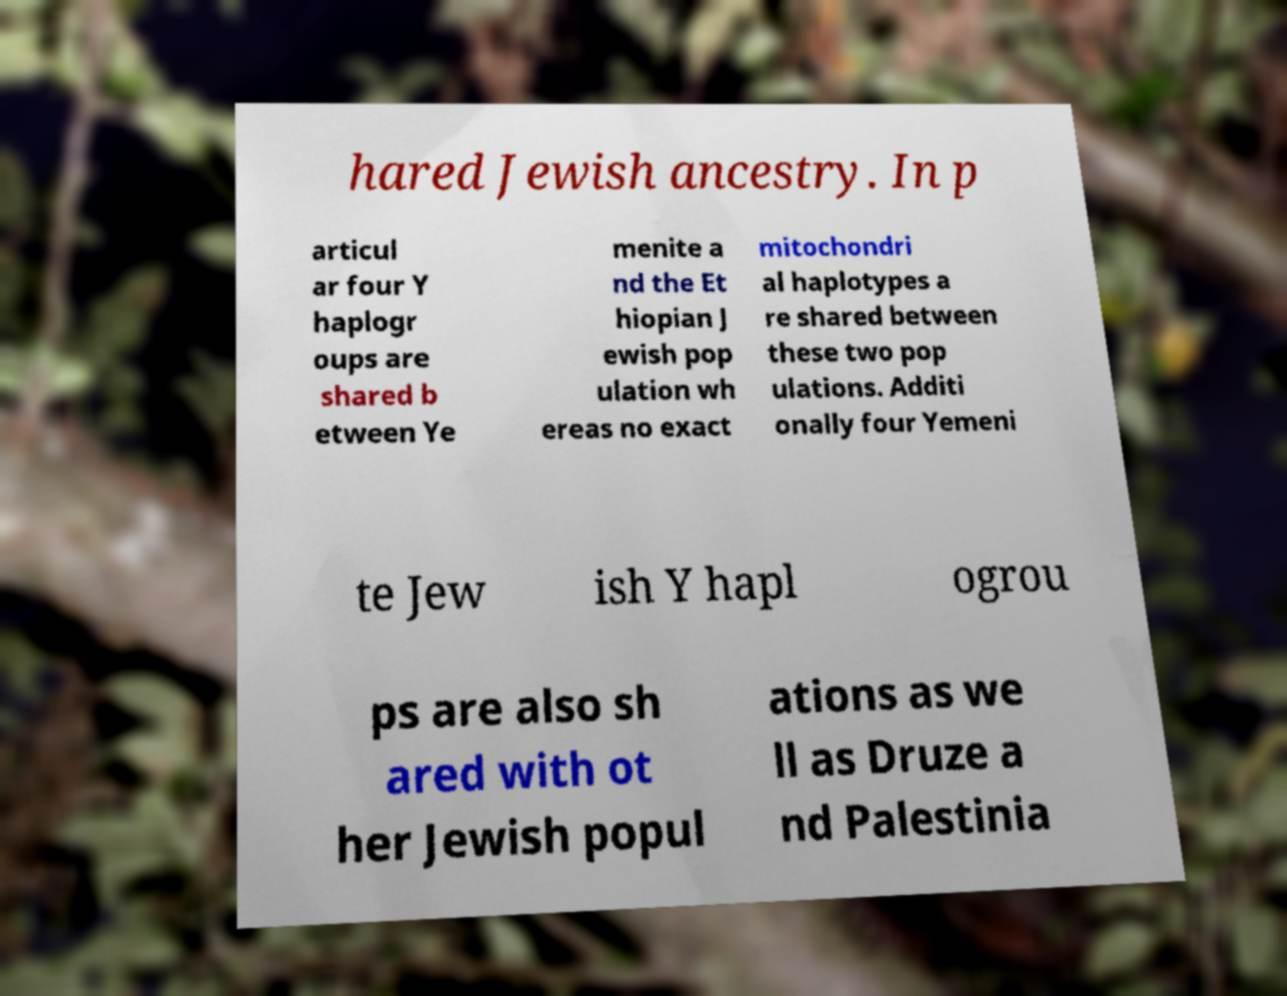What messages or text are displayed in this image? I need them in a readable, typed format. hared Jewish ancestry. In p articul ar four Y haplogr oups are shared b etween Ye menite a nd the Et hiopian J ewish pop ulation wh ereas no exact mitochondri al haplotypes a re shared between these two pop ulations. Additi onally four Yemeni te Jew ish Y hapl ogrou ps are also sh ared with ot her Jewish popul ations as we ll as Druze a nd Palestinia 